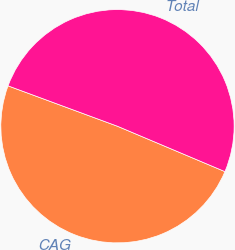<chart> <loc_0><loc_0><loc_500><loc_500><pie_chart><fcel>CAG<fcel>Total<nl><fcel>49.27%<fcel>50.73%<nl></chart> 